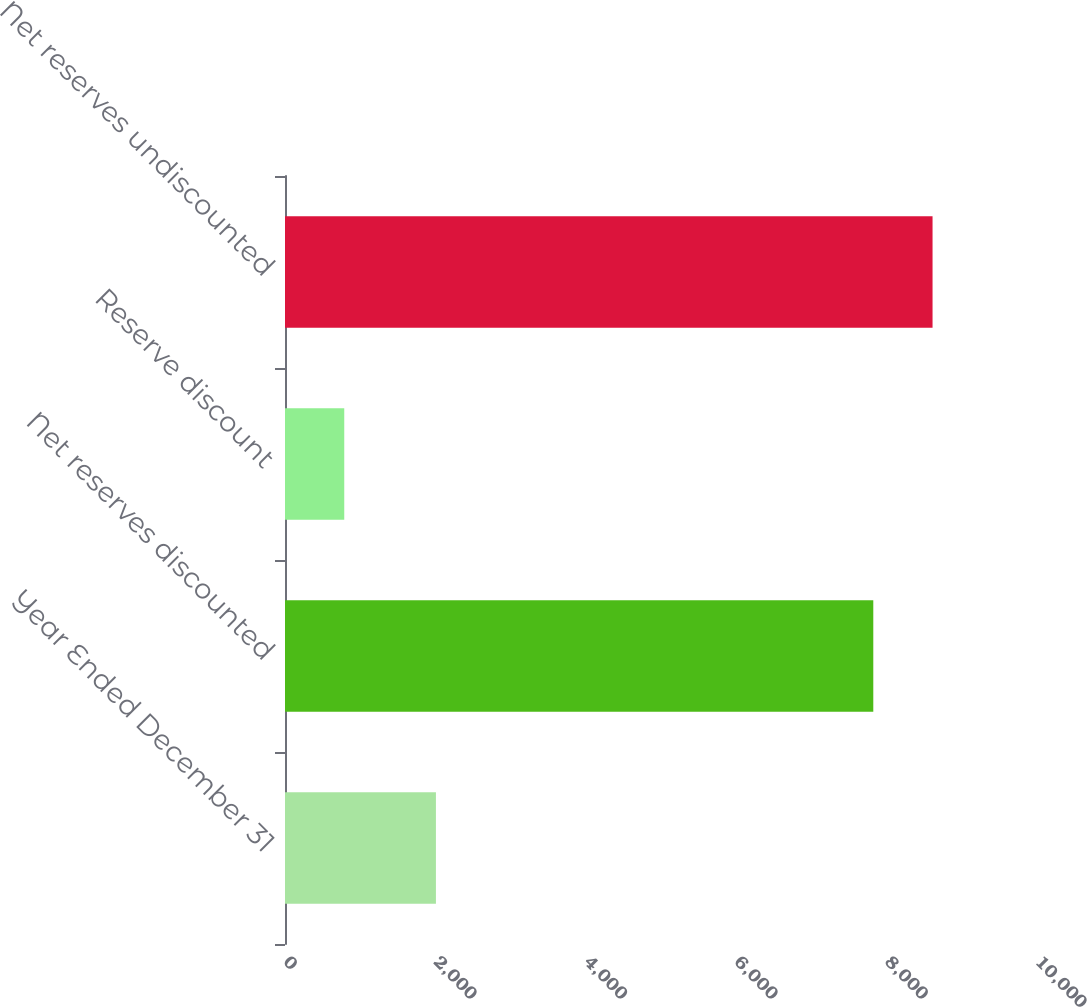<chart> <loc_0><loc_0><loc_500><loc_500><bar_chart><fcel>Year Ended December 31<fcel>Net reserves discounted<fcel>Reserve discount<fcel>Net reserves undiscounted<nl><fcel>2007<fcel>7823<fcel>788<fcel>8611<nl></chart> 